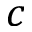Convert formula to latex. <formula><loc_0><loc_0><loc_500><loc_500>c</formula> 